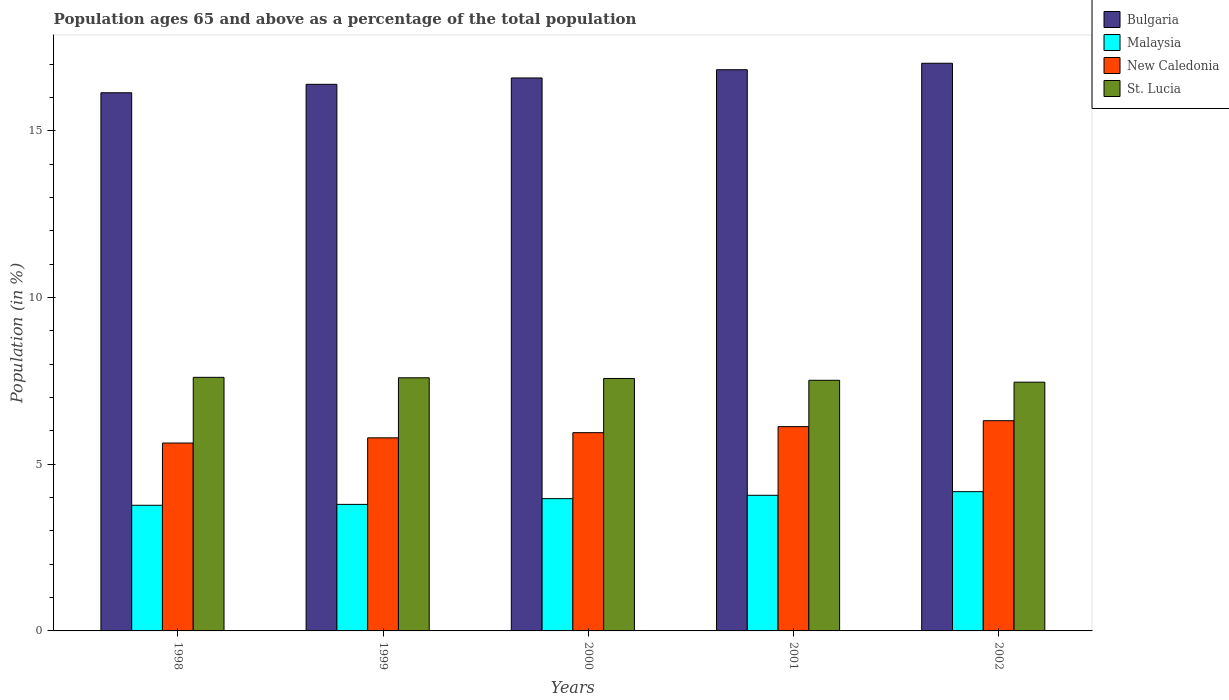How many groups of bars are there?
Give a very brief answer. 5. Are the number of bars per tick equal to the number of legend labels?
Offer a terse response. Yes. How many bars are there on the 5th tick from the left?
Ensure brevity in your answer.  4. How many bars are there on the 5th tick from the right?
Offer a very short reply. 4. What is the label of the 3rd group of bars from the left?
Provide a succinct answer. 2000. In how many cases, is the number of bars for a given year not equal to the number of legend labels?
Your answer should be very brief. 0. What is the percentage of the population ages 65 and above in New Caledonia in 2000?
Make the answer very short. 5.95. Across all years, what is the maximum percentage of the population ages 65 and above in New Caledonia?
Provide a succinct answer. 6.3. Across all years, what is the minimum percentage of the population ages 65 and above in Malaysia?
Offer a very short reply. 3.77. What is the total percentage of the population ages 65 and above in New Caledonia in the graph?
Your answer should be very brief. 29.8. What is the difference between the percentage of the population ages 65 and above in St. Lucia in 1999 and that in 2001?
Your response must be concise. 0.07. What is the difference between the percentage of the population ages 65 and above in Bulgaria in 1998 and the percentage of the population ages 65 and above in Malaysia in 1999?
Give a very brief answer. 12.34. What is the average percentage of the population ages 65 and above in St. Lucia per year?
Keep it short and to the point. 7.55. In the year 2000, what is the difference between the percentage of the population ages 65 and above in Bulgaria and percentage of the population ages 65 and above in Malaysia?
Your answer should be very brief. 12.61. In how many years, is the percentage of the population ages 65 and above in St. Lucia greater than 3?
Provide a succinct answer. 5. What is the ratio of the percentage of the population ages 65 and above in Malaysia in 1999 to that in 2002?
Keep it short and to the point. 0.91. Is the percentage of the population ages 65 and above in Malaysia in 2001 less than that in 2002?
Offer a very short reply. Yes. Is the difference between the percentage of the population ages 65 and above in Bulgaria in 1998 and 2000 greater than the difference between the percentage of the population ages 65 and above in Malaysia in 1998 and 2000?
Keep it short and to the point. No. What is the difference between the highest and the second highest percentage of the population ages 65 and above in St. Lucia?
Ensure brevity in your answer.  0.01. What is the difference between the highest and the lowest percentage of the population ages 65 and above in St. Lucia?
Your answer should be compact. 0.15. Is the sum of the percentage of the population ages 65 and above in New Caledonia in 1998 and 2002 greater than the maximum percentage of the population ages 65 and above in Bulgaria across all years?
Offer a terse response. No. Is it the case that in every year, the sum of the percentage of the population ages 65 and above in New Caledonia and percentage of the population ages 65 and above in Bulgaria is greater than the sum of percentage of the population ages 65 and above in St. Lucia and percentage of the population ages 65 and above in Malaysia?
Offer a terse response. Yes. What does the 3rd bar from the left in 1999 represents?
Keep it short and to the point. New Caledonia. What does the 3rd bar from the right in 2002 represents?
Offer a terse response. Malaysia. Are all the bars in the graph horizontal?
Offer a terse response. No. What is the difference between two consecutive major ticks on the Y-axis?
Make the answer very short. 5. Does the graph contain any zero values?
Offer a terse response. No. Does the graph contain grids?
Offer a very short reply. No. How many legend labels are there?
Your answer should be compact. 4. How are the legend labels stacked?
Ensure brevity in your answer.  Vertical. What is the title of the graph?
Your answer should be compact. Population ages 65 and above as a percentage of the total population. What is the Population (in %) in Bulgaria in 1998?
Make the answer very short. 16.14. What is the Population (in %) in Malaysia in 1998?
Your answer should be very brief. 3.77. What is the Population (in %) in New Caledonia in 1998?
Make the answer very short. 5.63. What is the Population (in %) of St. Lucia in 1998?
Provide a succinct answer. 7.6. What is the Population (in %) in Bulgaria in 1999?
Provide a short and direct response. 16.39. What is the Population (in %) in Malaysia in 1999?
Keep it short and to the point. 3.79. What is the Population (in %) of New Caledonia in 1999?
Give a very brief answer. 5.79. What is the Population (in %) of St. Lucia in 1999?
Provide a succinct answer. 7.59. What is the Population (in %) of Bulgaria in 2000?
Provide a short and direct response. 16.58. What is the Population (in %) of Malaysia in 2000?
Offer a terse response. 3.97. What is the Population (in %) of New Caledonia in 2000?
Provide a short and direct response. 5.95. What is the Population (in %) of St. Lucia in 2000?
Provide a succinct answer. 7.57. What is the Population (in %) of Bulgaria in 2001?
Give a very brief answer. 16.83. What is the Population (in %) of Malaysia in 2001?
Offer a very short reply. 4.07. What is the Population (in %) in New Caledonia in 2001?
Offer a terse response. 6.13. What is the Population (in %) in St. Lucia in 2001?
Offer a very short reply. 7.52. What is the Population (in %) in Bulgaria in 2002?
Give a very brief answer. 17.02. What is the Population (in %) in Malaysia in 2002?
Your response must be concise. 4.18. What is the Population (in %) of New Caledonia in 2002?
Your answer should be very brief. 6.3. What is the Population (in %) in St. Lucia in 2002?
Make the answer very short. 7.46. Across all years, what is the maximum Population (in %) in Bulgaria?
Give a very brief answer. 17.02. Across all years, what is the maximum Population (in %) in Malaysia?
Offer a terse response. 4.18. Across all years, what is the maximum Population (in %) in New Caledonia?
Keep it short and to the point. 6.3. Across all years, what is the maximum Population (in %) in St. Lucia?
Offer a very short reply. 7.6. Across all years, what is the minimum Population (in %) of Bulgaria?
Offer a very short reply. 16.14. Across all years, what is the minimum Population (in %) of Malaysia?
Give a very brief answer. 3.77. Across all years, what is the minimum Population (in %) in New Caledonia?
Your answer should be compact. 5.63. Across all years, what is the minimum Population (in %) in St. Lucia?
Offer a very short reply. 7.46. What is the total Population (in %) of Bulgaria in the graph?
Make the answer very short. 82.96. What is the total Population (in %) of Malaysia in the graph?
Your response must be concise. 19.77. What is the total Population (in %) in New Caledonia in the graph?
Your answer should be compact. 29.8. What is the total Population (in %) in St. Lucia in the graph?
Offer a very short reply. 37.74. What is the difference between the Population (in %) of Bulgaria in 1998 and that in 1999?
Give a very brief answer. -0.25. What is the difference between the Population (in %) of Malaysia in 1998 and that in 1999?
Provide a short and direct response. -0.03. What is the difference between the Population (in %) of New Caledonia in 1998 and that in 1999?
Your response must be concise. -0.16. What is the difference between the Population (in %) of St. Lucia in 1998 and that in 1999?
Your response must be concise. 0.01. What is the difference between the Population (in %) in Bulgaria in 1998 and that in 2000?
Keep it short and to the point. -0.44. What is the difference between the Population (in %) of Malaysia in 1998 and that in 2000?
Offer a terse response. -0.2. What is the difference between the Population (in %) in New Caledonia in 1998 and that in 2000?
Offer a terse response. -0.31. What is the difference between the Population (in %) of St. Lucia in 1998 and that in 2000?
Keep it short and to the point. 0.03. What is the difference between the Population (in %) of Bulgaria in 1998 and that in 2001?
Offer a very short reply. -0.69. What is the difference between the Population (in %) in Malaysia in 1998 and that in 2001?
Your response must be concise. -0.3. What is the difference between the Population (in %) in New Caledonia in 1998 and that in 2001?
Keep it short and to the point. -0.49. What is the difference between the Population (in %) in St. Lucia in 1998 and that in 2001?
Keep it short and to the point. 0.09. What is the difference between the Population (in %) in Bulgaria in 1998 and that in 2002?
Provide a succinct answer. -0.88. What is the difference between the Population (in %) in Malaysia in 1998 and that in 2002?
Your response must be concise. -0.41. What is the difference between the Population (in %) of New Caledonia in 1998 and that in 2002?
Offer a very short reply. -0.67. What is the difference between the Population (in %) of St. Lucia in 1998 and that in 2002?
Provide a succinct answer. 0.15. What is the difference between the Population (in %) of Bulgaria in 1999 and that in 2000?
Make the answer very short. -0.19. What is the difference between the Population (in %) of Malaysia in 1999 and that in 2000?
Provide a succinct answer. -0.17. What is the difference between the Population (in %) of New Caledonia in 1999 and that in 2000?
Your response must be concise. -0.15. What is the difference between the Population (in %) of St. Lucia in 1999 and that in 2000?
Keep it short and to the point. 0.02. What is the difference between the Population (in %) in Bulgaria in 1999 and that in 2001?
Provide a short and direct response. -0.44. What is the difference between the Population (in %) of Malaysia in 1999 and that in 2001?
Keep it short and to the point. -0.27. What is the difference between the Population (in %) of New Caledonia in 1999 and that in 2001?
Your answer should be compact. -0.34. What is the difference between the Population (in %) in St. Lucia in 1999 and that in 2001?
Offer a very short reply. 0.07. What is the difference between the Population (in %) in Bulgaria in 1999 and that in 2002?
Give a very brief answer. -0.63. What is the difference between the Population (in %) in Malaysia in 1999 and that in 2002?
Provide a succinct answer. -0.38. What is the difference between the Population (in %) of New Caledonia in 1999 and that in 2002?
Provide a short and direct response. -0.51. What is the difference between the Population (in %) in St. Lucia in 1999 and that in 2002?
Provide a succinct answer. 0.13. What is the difference between the Population (in %) of Bulgaria in 2000 and that in 2001?
Offer a very short reply. -0.25. What is the difference between the Population (in %) in Malaysia in 2000 and that in 2001?
Keep it short and to the point. -0.1. What is the difference between the Population (in %) in New Caledonia in 2000 and that in 2001?
Make the answer very short. -0.18. What is the difference between the Population (in %) of St. Lucia in 2000 and that in 2001?
Provide a short and direct response. 0.05. What is the difference between the Population (in %) of Bulgaria in 2000 and that in 2002?
Your answer should be compact. -0.44. What is the difference between the Population (in %) of Malaysia in 2000 and that in 2002?
Give a very brief answer. -0.21. What is the difference between the Population (in %) of New Caledonia in 2000 and that in 2002?
Offer a terse response. -0.36. What is the difference between the Population (in %) in St. Lucia in 2000 and that in 2002?
Offer a very short reply. 0.11. What is the difference between the Population (in %) in Bulgaria in 2001 and that in 2002?
Offer a terse response. -0.19. What is the difference between the Population (in %) in Malaysia in 2001 and that in 2002?
Your response must be concise. -0.11. What is the difference between the Population (in %) of New Caledonia in 2001 and that in 2002?
Provide a succinct answer. -0.18. What is the difference between the Population (in %) of St. Lucia in 2001 and that in 2002?
Ensure brevity in your answer.  0.06. What is the difference between the Population (in %) in Bulgaria in 1998 and the Population (in %) in Malaysia in 1999?
Provide a succinct answer. 12.34. What is the difference between the Population (in %) of Bulgaria in 1998 and the Population (in %) of New Caledonia in 1999?
Your answer should be very brief. 10.35. What is the difference between the Population (in %) of Bulgaria in 1998 and the Population (in %) of St. Lucia in 1999?
Your answer should be compact. 8.55. What is the difference between the Population (in %) in Malaysia in 1998 and the Population (in %) in New Caledonia in 1999?
Offer a terse response. -2.02. What is the difference between the Population (in %) in Malaysia in 1998 and the Population (in %) in St. Lucia in 1999?
Provide a succinct answer. -3.82. What is the difference between the Population (in %) in New Caledonia in 1998 and the Population (in %) in St. Lucia in 1999?
Provide a short and direct response. -1.96. What is the difference between the Population (in %) in Bulgaria in 1998 and the Population (in %) in Malaysia in 2000?
Your answer should be very brief. 12.17. What is the difference between the Population (in %) in Bulgaria in 1998 and the Population (in %) in New Caledonia in 2000?
Provide a succinct answer. 10.19. What is the difference between the Population (in %) in Bulgaria in 1998 and the Population (in %) in St. Lucia in 2000?
Offer a very short reply. 8.57. What is the difference between the Population (in %) of Malaysia in 1998 and the Population (in %) of New Caledonia in 2000?
Keep it short and to the point. -2.18. What is the difference between the Population (in %) of Malaysia in 1998 and the Population (in %) of St. Lucia in 2000?
Provide a succinct answer. -3.8. What is the difference between the Population (in %) of New Caledonia in 1998 and the Population (in %) of St. Lucia in 2000?
Offer a terse response. -1.94. What is the difference between the Population (in %) in Bulgaria in 1998 and the Population (in %) in Malaysia in 2001?
Provide a succinct answer. 12.07. What is the difference between the Population (in %) in Bulgaria in 1998 and the Population (in %) in New Caledonia in 2001?
Provide a succinct answer. 10.01. What is the difference between the Population (in %) of Bulgaria in 1998 and the Population (in %) of St. Lucia in 2001?
Keep it short and to the point. 8.62. What is the difference between the Population (in %) of Malaysia in 1998 and the Population (in %) of New Caledonia in 2001?
Provide a succinct answer. -2.36. What is the difference between the Population (in %) in Malaysia in 1998 and the Population (in %) in St. Lucia in 2001?
Your response must be concise. -3.75. What is the difference between the Population (in %) of New Caledonia in 1998 and the Population (in %) of St. Lucia in 2001?
Provide a succinct answer. -1.88. What is the difference between the Population (in %) in Bulgaria in 1998 and the Population (in %) in Malaysia in 2002?
Ensure brevity in your answer.  11.96. What is the difference between the Population (in %) of Bulgaria in 1998 and the Population (in %) of New Caledonia in 2002?
Give a very brief answer. 9.83. What is the difference between the Population (in %) of Bulgaria in 1998 and the Population (in %) of St. Lucia in 2002?
Ensure brevity in your answer.  8.68. What is the difference between the Population (in %) in Malaysia in 1998 and the Population (in %) in New Caledonia in 2002?
Your answer should be compact. -2.54. What is the difference between the Population (in %) of Malaysia in 1998 and the Population (in %) of St. Lucia in 2002?
Provide a succinct answer. -3.69. What is the difference between the Population (in %) in New Caledonia in 1998 and the Population (in %) in St. Lucia in 2002?
Ensure brevity in your answer.  -1.83. What is the difference between the Population (in %) of Bulgaria in 1999 and the Population (in %) of Malaysia in 2000?
Offer a terse response. 12.42. What is the difference between the Population (in %) in Bulgaria in 1999 and the Population (in %) in New Caledonia in 2000?
Your answer should be very brief. 10.45. What is the difference between the Population (in %) of Bulgaria in 1999 and the Population (in %) of St. Lucia in 2000?
Offer a very short reply. 8.82. What is the difference between the Population (in %) of Malaysia in 1999 and the Population (in %) of New Caledonia in 2000?
Make the answer very short. -2.15. What is the difference between the Population (in %) of Malaysia in 1999 and the Population (in %) of St. Lucia in 2000?
Your answer should be compact. -3.78. What is the difference between the Population (in %) in New Caledonia in 1999 and the Population (in %) in St. Lucia in 2000?
Ensure brevity in your answer.  -1.78. What is the difference between the Population (in %) of Bulgaria in 1999 and the Population (in %) of Malaysia in 2001?
Your answer should be very brief. 12.32. What is the difference between the Population (in %) of Bulgaria in 1999 and the Population (in %) of New Caledonia in 2001?
Your answer should be compact. 10.26. What is the difference between the Population (in %) in Bulgaria in 1999 and the Population (in %) in St. Lucia in 2001?
Provide a short and direct response. 8.88. What is the difference between the Population (in %) of Malaysia in 1999 and the Population (in %) of New Caledonia in 2001?
Your answer should be very brief. -2.33. What is the difference between the Population (in %) of Malaysia in 1999 and the Population (in %) of St. Lucia in 2001?
Your response must be concise. -3.72. What is the difference between the Population (in %) in New Caledonia in 1999 and the Population (in %) in St. Lucia in 2001?
Give a very brief answer. -1.73. What is the difference between the Population (in %) in Bulgaria in 1999 and the Population (in %) in Malaysia in 2002?
Your answer should be compact. 12.21. What is the difference between the Population (in %) of Bulgaria in 1999 and the Population (in %) of New Caledonia in 2002?
Offer a very short reply. 10.09. What is the difference between the Population (in %) in Bulgaria in 1999 and the Population (in %) in St. Lucia in 2002?
Your response must be concise. 8.93. What is the difference between the Population (in %) in Malaysia in 1999 and the Population (in %) in New Caledonia in 2002?
Provide a succinct answer. -2.51. What is the difference between the Population (in %) of Malaysia in 1999 and the Population (in %) of St. Lucia in 2002?
Offer a very short reply. -3.66. What is the difference between the Population (in %) of New Caledonia in 1999 and the Population (in %) of St. Lucia in 2002?
Keep it short and to the point. -1.67. What is the difference between the Population (in %) in Bulgaria in 2000 and the Population (in %) in Malaysia in 2001?
Offer a very short reply. 12.51. What is the difference between the Population (in %) of Bulgaria in 2000 and the Population (in %) of New Caledonia in 2001?
Ensure brevity in your answer.  10.46. What is the difference between the Population (in %) of Bulgaria in 2000 and the Population (in %) of St. Lucia in 2001?
Your answer should be very brief. 9.07. What is the difference between the Population (in %) of Malaysia in 2000 and the Population (in %) of New Caledonia in 2001?
Your answer should be very brief. -2.16. What is the difference between the Population (in %) in Malaysia in 2000 and the Population (in %) in St. Lucia in 2001?
Offer a terse response. -3.55. What is the difference between the Population (in %) of New Caledonia in 2000 and the Population (in %) of St. Lucia in 2001?
Your response must be concise. -1.57. What is the difference between the Population (in %) of Bulgaria in 2000 and the Population (in %) of Malaysia in 2002?
Your response must be concise. 12.41. What is the difference between the Population (in %) of Bulgaria in 2000 and the Population (in %) of New Caledonia in 2002?
Provide a short and direct response. 10.28. What is the difference between the Population (in %) of Bulgaria in 2000 and the Population (in %) of St. Lucia in 2002?
Provide a succinct answer. 9.12. What is the difference between the Population (in %) in Malaysia in 2000 and the Population (in %) in New Caledonia in 2002?
Provide a succinct answer. -2.34. What is the difference between the Population (in %) of Malaysia in 2000 and the Population (in %) of St. Lucia in 2002?
Your answer should be compact. -3.49. What is the difference between the Population (in %) in New Caledonia in 2000 and the Population (in %) in St. Lucia in 2002?
Make the answer very short. -1.51. What is the difference between the Population (in %) of Bulgaria in 2001 and the Population (in %) of Malaysia in 2002?
Provide a succinct answer. 12.65. What is the difference between the Population (in %) of Bulgaria in 2001 and the Population (in %) of New Caledonia in 2002?
Ensure brevity in your answer.  10.52. What is the difference between the Population (in %) of Bulgaria in 2001 and the Population (in %) of St. Lucia in 2002?
Make the answer very short. 9.37. What is the difference between the Population (in %) in Malaysia in 2001 and the Population (in %) in New Caledonia in 2002?
Ensure brevity in your answer.  -2.24. What is the difference between the Population (in %) in Malaysia in 2001 and the Population (in %) in St. Lucia in 2002?
Offer a very short reply. -3.39. What is the difference between the Population (in %) in New Caledonia in 2001 and the Population (in %) in St. Lucia in 2002?
Keep it short and to the point. -1.33. What is the average Population (in %) of Bulgaria per year?
Ensure brevity in your answer.  16.59. What is the average Population (in %) in Malaysia per year?
Provide a succinct answer. 3.95. What is the average Population (in %) in New Caledonia per year?
Make the answer very short. 5.96. What is the average Population (in %) of St. Lucia per year?
Ensure brevity in your answer.  7.55. In the year 1998, what is the difference between the Population (in %) in Bulgaria and Population (in %) in Malaysia?
Give a very brief answer. 12.37. In the year 1998, what is the difference between the Population (in %) in Bulgaria and Population (in %) in New Caledonia?
Your response must be concise. 10.5. In the year 1998, what is the difference between the Population (in %) of Bulgaria and Population (in %) of St. Lucia?
Offer a very short reply. 8.53. In the year 1998, what is the difference between the Population (in %) in Malaysia and Population (in %) in New Caledonia?
Your answer should be very brief. -1.87. In the year 1998, what is the difference between the Population (in %) in Malaysia and Population (in %) in St. Lucia?
Offer a very short reply. -3.84. In the year 1998, what is the difference between the Population (in %) of New Caledonia and Population (in %) of St. Lucia?
Provide a short and direct response. -1.97. In the year 1999, what is the difference between the Population (in %) in Bulgaria and Population (in %) in Malaysia?
Offer a terse response. 12.6. In the year 1999, what is the difference between the Population (in %) in Bulgaria and Population (in %) in New Caledonia?
Provide a succinct answer. 10.6. In the year 1999, what is the difference between the Population (in %) of Bulgaria and Population (in %) of St. Lucia?
Give a very brief answer. 8.8. In the year 1999, what is the difference between the Population (in %) in Malaysia and Population (in %) in New Caledonia?
Make the answer very short. -2. In the year 1999, what is the difference between the Population (in %) in Malaysia and Population (in %) in St. Lucia?
Your answer should be very brief. -3.8. In the year 1999, what is the difference between the Population (in %) of New Caledonia and Population (in %) of St. Lucia?
Make the answer very short. -1.8. In the year 2000, what is the difference between the Population (in %) of Bulgaria and Population (in %) of Malaysia?
Your response must be concise. 12.61. In the year 2000, what is the difference between the Population (in %) in Bulgaria and Population (in %) in New Caledonia?
Provide a short and direct response. 10.64. In the year 2000, what is the difference between the Population (in %) in Bulgaria and Population (in %) in St. Lucia?
Make the answer very short. 9.01. In the year 2000, what is the difference between the Population (in %) of Malaysia and Population (in %) of New Caledonia?
Provide a succinct answer. -1.98. In the year 2000, what is the difference between the Population (in %) in Malaysia and Population (in %) in St. Lucia?
Your answer should be compact. -3.6. In the year 2000, what is the difference between the Population (in %) of New Caledonia and Population (in %) of St. Lucia?
Provide a succinct answer. -1.63. In the year 2001, what is the difference between the Population (in %) of Bulgaria and Population (in %) of Malaysia?
Provide a succinct answer. 12.76. In the year 2001, what is the difference between the Population (in %) of Bulgaria and Population (in %) of New Caledonia?
Provide a short and direct response. 10.7. In the year 2001, what is the difference between the Population (in %) of Bulgaria and Population (in %) of St. Lucia?
Provide a short and direct response. 9.31. In the year 2001, what is the difference between the Population (in %) of Malaysia and Population (in %) of New Caledonia?
Offer a very short reply. -2.06. In the year 2001, what is the difference between the Population (in %) in Malaysia and Population (in %) in St. Lucia?
Make the answer very short. -3.45. In the year 2001, what is the difference between the Population (in %) of New Caledonia and Population (in %) of St. Lucia?
Offer a very short reply. -1.39. In the year 2002, what is the difference between the Population (in %) of Bulgaria and Population (in %) of Malaysia?
Offer a very short reply. 12.85. In the year 2002, what is the difference between the Population (in %) in Bulgaria and Population (in %) in New Caledonia?
Make the answer very short. 10.72. In the year 2002, what is the difference between the Population (in %) in Bulgaria and Population (in %) in St. Lucia?
Your response must be concise. 9.56. In the year 2002, what is the difference between the Population (in %) in Malaysia and Population (in %) in New Caledonia?
Your answer should be very brief. -2.13. In the year 2002, what is the difference between the Population (in %) in Malaysia and Population (in %) in St. Lucia?
Your answer should be compact. -3.28. In the year 2002, what is the difference between the Population (in %) of New Caledonia and Population (in %) of St. Lucia?
Your answer should be compact. -1.16. What is the ratio of the Population (in %) in Bulgaria in 1998 to that in 1999?
Make the answer very short. 0.98. What is the ratio of the Population (in %) of Malaysia in 1998 to that in 1999?
Provide a short and direct response. 0.99. What is the ratio of the Population (in %) of New Caledonia in 1998 to that in 1999?
Your response must be concise. 0.97. What is the ratio of the Population (in %) of Bulgaria in 1998 to that in 2000?
Provide a short and direct response. 0.97. What is the ratio of the Population (in %) of Malaysia in 1998 to that in 2000?
Give a very brief answer. 0.95. What is the ratio of the Population (in %) in New Caledonia in 1998 to that in 2000?
Give a very brief answer. 0.95. What is the ratio of the Population (in %) of Malaysia in 1998 to that in 2001?
Provide a short and direct response. 0.93. What is the ratio of the Population (in %) in New Caledonia in 1998 to that in 2001?
Provide a short and direct response. 0.92. What is the ratio of the Population (in %) in St. Lucia in 1998 to that in 2001?
Keep it short and to the point. 1.01. What is the ratio of the Population (in %) in Bulgaria in 1998 to that in 2002?
Keep it short and to the point. 0.95. What is the ratio of the Population (in %) in Malaysia in 1998 to that in 2002?
Ensure brevity in your answer.  0.9. What is the ratio of the Population (in %) of New Caledonia in 1998 to that in 2002?
Your answer should be compact. 0.89. What is the ratio of the Population (in %) in St. Lucia in 1998 to that in 2002?
Give a very brief answer. 1.02. What is the ratio of the Population (in %) in Malaysia in 1999 to that in 2000?
Provide a succinct answer. 0.96. What is the ratio of the Population (in %) in New Caledonia in 1999 to that in 2000?
Give a very brief answer. 0.97. What is the ratio of the Population (in %) in Malaysia in 1999 to that in 2001?
Offer a terse response. 0.93. What is the ratio of the Population (in %) of New Caledonia in 1999 to that in 2001?
Ensure brevity in your answer.  0.95. What is the ratio of the Population (in %) of St. Lucia in 1999 to that in 2001?
Your answer should be compact. 1.01. What is the ratio of the Population (in %) of Bulgaria in 1999 to that in 2002?
Ensure brevity in your answer.  0.96. What is the ratio of the Population (in %) of Malaysia in 1999 to that in 2002?
Ensure brevity in your answer.  0.91. What is the ratio of the Population (in %) in New Caledonia in 1999 to that in 2002?
Give a very brief answer. 0.92. What is the ratio of the Population (in %) in St. Lucia in 1999 to that in 2002?
Provide a short and direct response. 1.02. What is the ratio of the Population (in %) of Malaysia in 2000 to that in 2001?
Provide a succinct answer. 0.98. What is the ratio of the Population (in %) in New Caledonia in 2000 to that in 2001?
Provide a succinct answer. 0.97. What is the ratio of the Population (in %) in St. Lucia in 2000 to that in 2001?
Provide a short and direct response. 1.01. What is the ratio of the Population (in %) in Bulgaria in 2000 to that in 2002?
Make the answer very short. 0.97. What is the ratio of the Population (in %) of Malaysia in 2000 to that in 2002?
Your answer should be compact. 0.95. What is the ratio of the Population (in %) of New Caledonia in 2000 to that in 2002?
Provide a succinct answer. 0.94. What is the ratio of the Population (in %) of St. Lucia in 2000 to that in 2002?
Keep it short and to the point. 1.01. What is the ratio of the Population (in %) in New Caledonia in 2001 to that in 2002?
Provide a succinct answer. 0.97. What is the ratio of the Population (in %) of St. Lucia in 2001 to that in 2002?
Offer a very short reply. 1.01. What is the difference between the highest and the second highest Population (in %) of Bulgaria?
Provide a short and direct response. 0.19. What is the difference between the highest and the second highest Population (in %) in Malaysia?
Make the answer very short. 0.11. What is the difference between the highest and the second highest Population (in %) in New Caledonia?
Ensure brevity in your answer.  0.18. What is the difference between the highest and the second highest Population (in %) in St. Lucia?
Offer a terse response. 0.01. What is the difference between the highest and the lowest Population (in %) in Bulgaria?
Your answer should be compact. 0.88. What is the difference between the highest and the lowest Population (in %) of Malaysia?
Offer a very short reply. 0.41. What is the difference between the highest and the lowest Population (in %) in New Caledonia?
Provide a short and direct response. 0.67. What is the difference between the highest and the lowest Population (in %) of St. Lucia?
Keep it short and to the point. 0.15. 